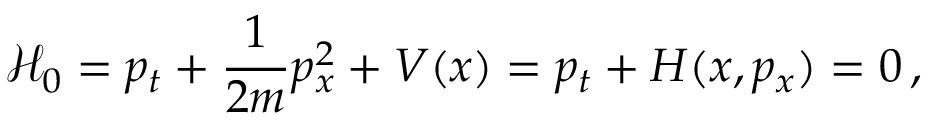<formula> <loc_0><loc_0><loc_500><loc_500>\mathcal { H } _ { 0 } = p _ { t } + \frac { 1 } { 2 m } p _ { x } ^ { 2 } + V ( x ) = p _ { t } + H ( x , p _ { x } ) = 0 \, ,</formula> 